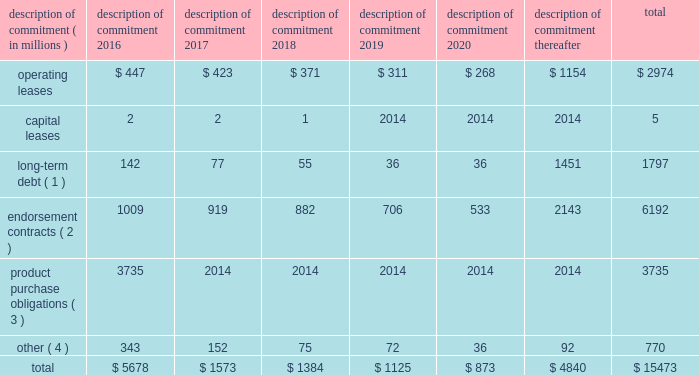Part ii were issued in an initial aggregate principal amount of $ 500 million at a 2.25% ( 2.25 % ) fixed , annual interest rate and will mature on may 1 , 2023 .
The 2043 senior notes were issued in an initial aggregate principal amount of $ 500 million at a 3.625% ( 3.625 % ) fixed , annual interest rate and will mature on may 1 , 2043 .
Interest on the senior notes is payable semi-annually on may 1 and november 1 of each year .
The issuance resulted in gross proceeds before expenses of $ 998 million .
On november 1 , 2011 , we entered into a committed credit facility agreement with a syndicate of banks which provides for up to $ 1 billion of borrowings with the option to increase borrowings to $ 1.5 billion with lender approval .
The facility matures november 1 , 2017 .
As of and for the periods ended may 31 , 2015 and 2014 , we had no amounts outstanding under our committed credit facility .
We currently have long-term debt ratings of aa- and a1 from standard and poor 2019s corporation and moody 2019s investor services , respectively .
If our long- term debt ratings were to decline , the facility fee and interest rate under our committed credit facility would increase .
Conversely , if our long-term debt rating were to improve , the facility fee and interest rate would decrease .
Changes in our long-term debt rating would not trigger acceleration of maturity of any then-outstanding borrowings or any future borrowings under the committed credit facility .
Under this committed revolving credit facility , we have agreed to various covenants .
These covenants include limits on our disposal of fixed assets , the amount of debt secured by liens we may incur , as well as a minimum capitalization ratio .
In the event we were to have any borrowings outstanding under this facility and failed to meet any covenant , and were unable to obtain a waiver from a majority of the banks in the syndicate , any borrowings would become immediately due and payable .
As of may 31 , 2015 , we were in full compliance with each of these covenants and believe it is unlikely we will fail to meet any of these covenants in the foreseeable future .
Liquidity is also provided by our $ 1 billion commercial paper program .
During the year ended may 31 , 2015 , we did not issue commercial paper , and as of may 31 , 2015 , there were no outstanding borrowings under this program .
We may issue commercial paper or other debt securities during fiscal 2016 depending on general corporate needs .
We currently have short-term debt ratings of a1+ and p1 from standard and poor 2019s corporation and moody 2019s investor services , respectively .
As of may 31 , 2015 , we had cash , cash equivalents and short-term investments totaling $ 5.9 billion , of which $ 4.2 billion was held by our foreign subsidiaries .
Included in cash and equivalents as of may 31 , 2015 was $ 968 million of cash collateral received from counterparties as a result of hedging activity .
Cash equivalents and short-term investments consist primarily of deposits held at major banks , money market funds , commercial paper , corporate notes , u.s .
Treasury obligations , u.s .
Government sponsored enterprise obligations and other investment grade fixed income securities .
Our fixed income investments are exposed to both credit and interest rate risk .
All of our investments are investment grade to minimize our credit risk .
While individual securities have varying durations , as of may 31 , 2015 the weighted average remaining duration of our short-term investments and cash equivalents portfolio was 79 days .
To date we have not experienced difficulty accessing the credit markets or incurred higher interest costs .
Future volatility in the capital markets , however , may increase costs associated with issuing commercial paper or other debt instruments or affect our ability to access those markets .
We believe that existing cash , cash equivalents , short-term investments and cash generated by operations , together with access to external sources of funds as described above , will be sufficient to meet our domestic and foreign capital needs in the foreseeable future .
We utilize a variety of tax planning and financing strategies to manage our worldwide cash and deploy funds to locations where they are needed .
We routinely repatriate a portion of our foreign earnings for which u.s .
Taxes have previously been provided .
We also indefinitely reinvest a significant portion of our foreign earnings , and our current plans do not demonstrate a need to repatriate these earnings .
Should we require additional capital in the united states , we may elect to repatriate indefinitely reinvested foreign funds or raise capital in the united states through debt .
If we were to repatriate indefinitely reinvested foreign funds , we would be required to accrue and pay additional u.s .
Taxes less applicable foreign tax credits .
If we elect to raise capital in the united states through debt , we would incur additional interest expense .
Off-balance sheet arrangements in connection with various contracts and agreements , we routinely provide indemnification relating to the enforceability of intellectual property rights , coverage for legal issues that arise and other items where we are acting as the guarantor .
Currently , we have several such agreements in place .
However , based on our historical experience and the estimated probability of future loss , we have determined that the fair value of such indemnification is not material to our financial position or results of operations .
Contractual obligations our significant long-term contractual obligations as of may 31 , 2015 and significant endorsement contracts , including related marketing commitments , entered into through the date of this report are as follows: .
( 1 ) the cash payments due for long-term debt include estimated interest payments .
Estimates of interest payments are based on outstanding principal amounts , applicable fixed interest rates or currently effective interest rates as of may 31 , 2015 ( if variable ) , timing of scheduled payments and the term of the debt obligations .
( 2 ) the amounts listed for endorsement contracts represent approximate amounts of base compensation and minimum guaranteed royalty fees we are obligated to pay athlete , sport team and league endorsers of our products .
Actual payments under some contracts may be higher than the amounts listed as these contracts provide for bonuses to be paid to the endorsers based upon athletic achievements and/or royalties on product sales in future periods .
Actual payments under some contracts may also be lower as these contracts include provisions for reduced payments if athletic performance declines in future periods .
In addition to the cash payments , we are obligated to furnish our endorsers with nike product for their use .
It is not possible to determine how much we will spend on this product on an annual basis as the contracts generally do not stipulate a specific amount of cash to be spent on the product .
The amount of product provided to the endorsers will depend on many factors , including general playing conditions , the number of sporting events in which they participate and our own decisions regarding product and marketing initiatives .
In addition , the costs to design , develop , source and purchase the products furnished to the endorsers are incurred over a period of time and are not necessarily tracked separately from similar costs incurred for products sold to customers. .
What percent of the total for 2017 was due to endorsement contracts? 
Computations: (919 / 1573)
Answer: 0.58423. 